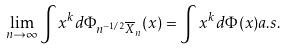<formula> <loc_0><loc_0><loc_500><loc_500>\lim _ { n \rightarrow \infty } \int x ^ { k } d \Phi _ { n ^ { - 1 / 2 } \overline { X } _ { n } } ( x ) = \int x ^ { k } d \Phi ( x ) a . s .</formula> 